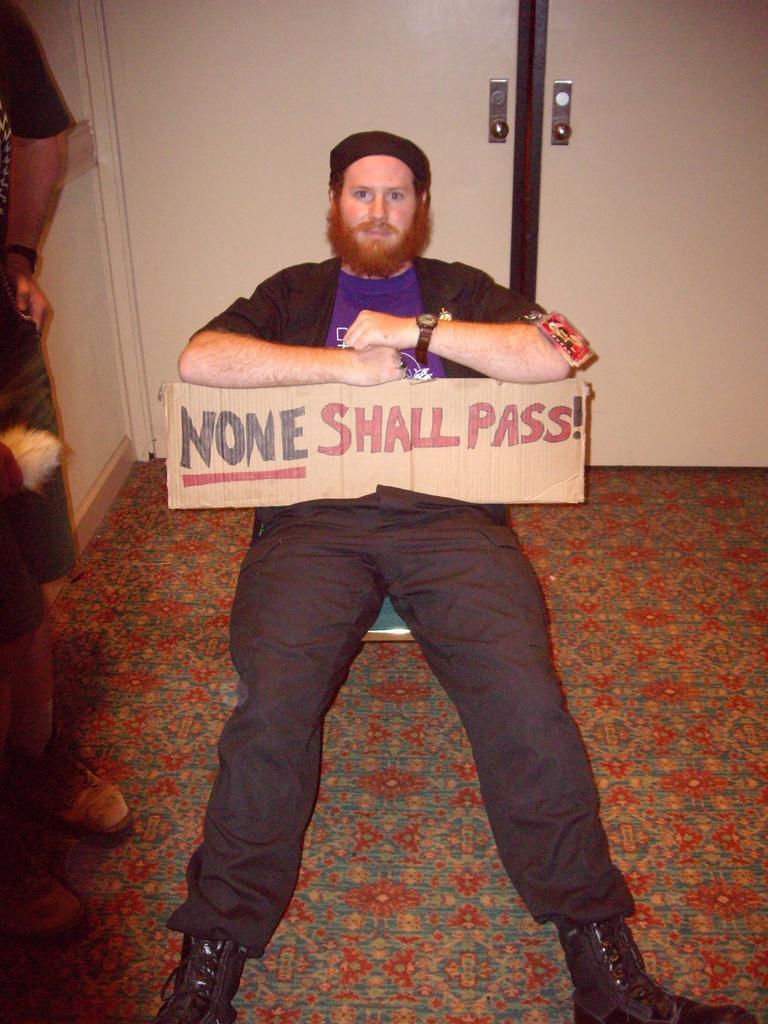Describe this image in one or two sentences. In this picture, we can see a man is sitting on the floor and holding a cardboard sheet and on the left side of the man there is another person. Behind the man there is a door. 